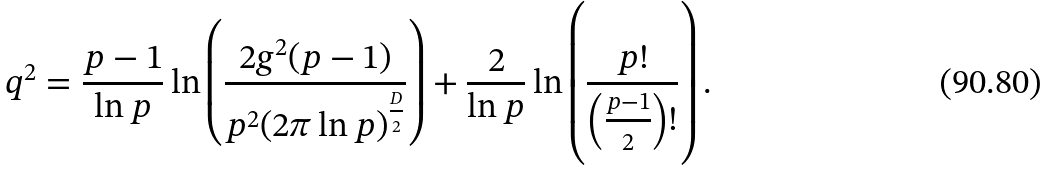<formula> <loc_0><loc_0><loc_500><loc_500>q ^ { 2 } = \frac { p - 1 } { \ln p } \ln \left ( \frac { 2 g ^ { 2 } ( p - 1 ) } { p ^ { 2 } ( 2 \pi \ln p ) ^ { \frac { D } { 2 } } } \right ) + \frac { 2 } { \ln p } \ln \left ( \frac { p ! } { \left ( \frac { p - 1 } { 2 } \right ) ! } \right ) .</formula> 